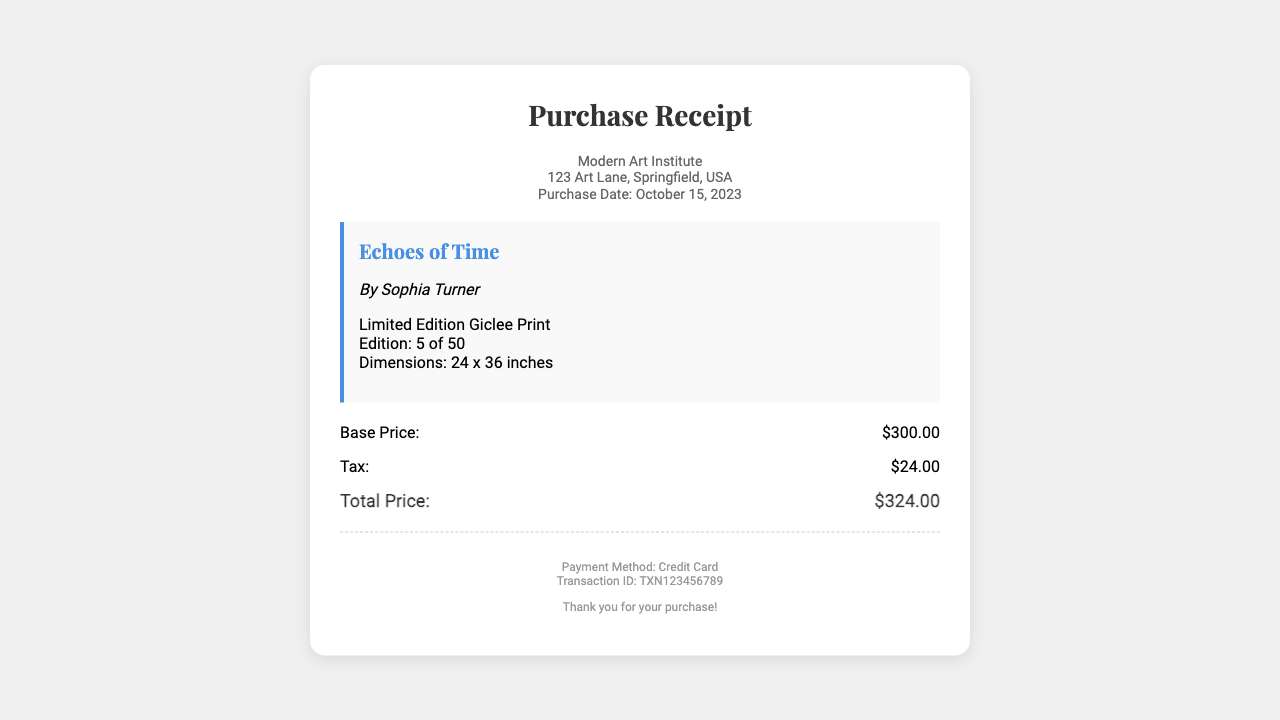What is the name of the gallery? The name of the gallery is provided in the header section of the receipt.
Answer: Modern Art Institute Who is the artist? The artist's name is mentioned under the artwork title.
Answer: Sophia Turner What is the title of the artwork? The title of the artwork is displayed prominently in the artwork information section.
Answer: Echoes of Time What is the base price of the print? The base price is listed in the price breakdown section of the receipt.
Answer: $300.00 What is the tax amount? The tax amount is specified in the price breakdown section of the receipt.
Answer: $24.00 What is the total price of the purchase? The total price is summarized in the price breakdown section, combining base price and tax.
Answer: $324.00 What is the edition number of the print? The edition number is noted in the artwork information section of the receipt.
Answer: 5 of 50 What payment method was used? The payment method is provided in the footer section of the receipt.
Answer: Credit Card What is the transaction ID? The transaction ID is detailed in the footer section.
Answer: TXN123456789 